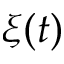Convert formula to latex. <formula><loc_0><loc_0><loc_500><loc_500>\xi ( t )</formula> 